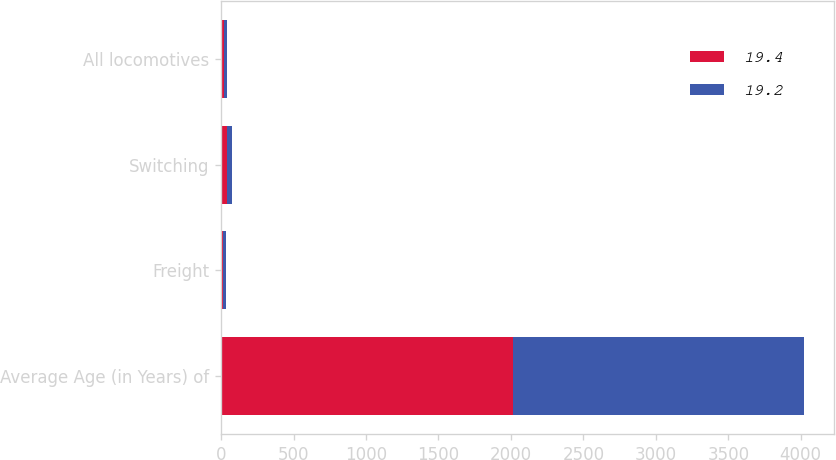<chart> <loc_0><loc_0><loc_500><loc_500><stacked_bar_chart><ecel><fcel>Average Age (in Years) of<fcel>Freight<fcel>Switching<fcel>All locomotives<nl><fcel>19.4<fcel>2013<fcel>16<fcel>37.2<fcel>19.4<nl><fcel>19.2<fcel>2012<fcel>15.7<fcel>36.4<fcel>19.2<nl></chart> 